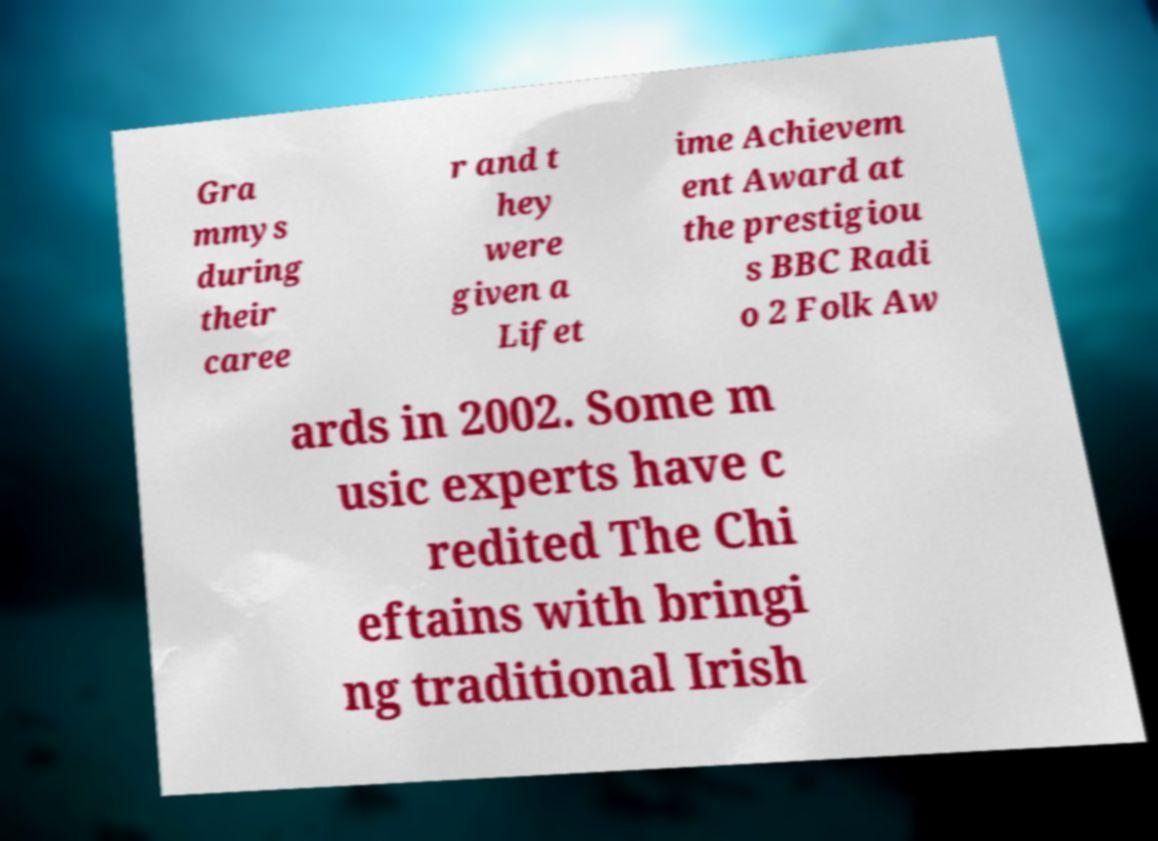Could you assist in decoding the text presented in this image and type it out clearly? Gra mmys during their caree r and t hey were given a Lifet ime Achievem ent Award at the prestigiou s BBC Radi o 2 Folk Aw ards in 2002. Some m usic experts have c redited The Chi eftains with bringi ng traditional Irish 